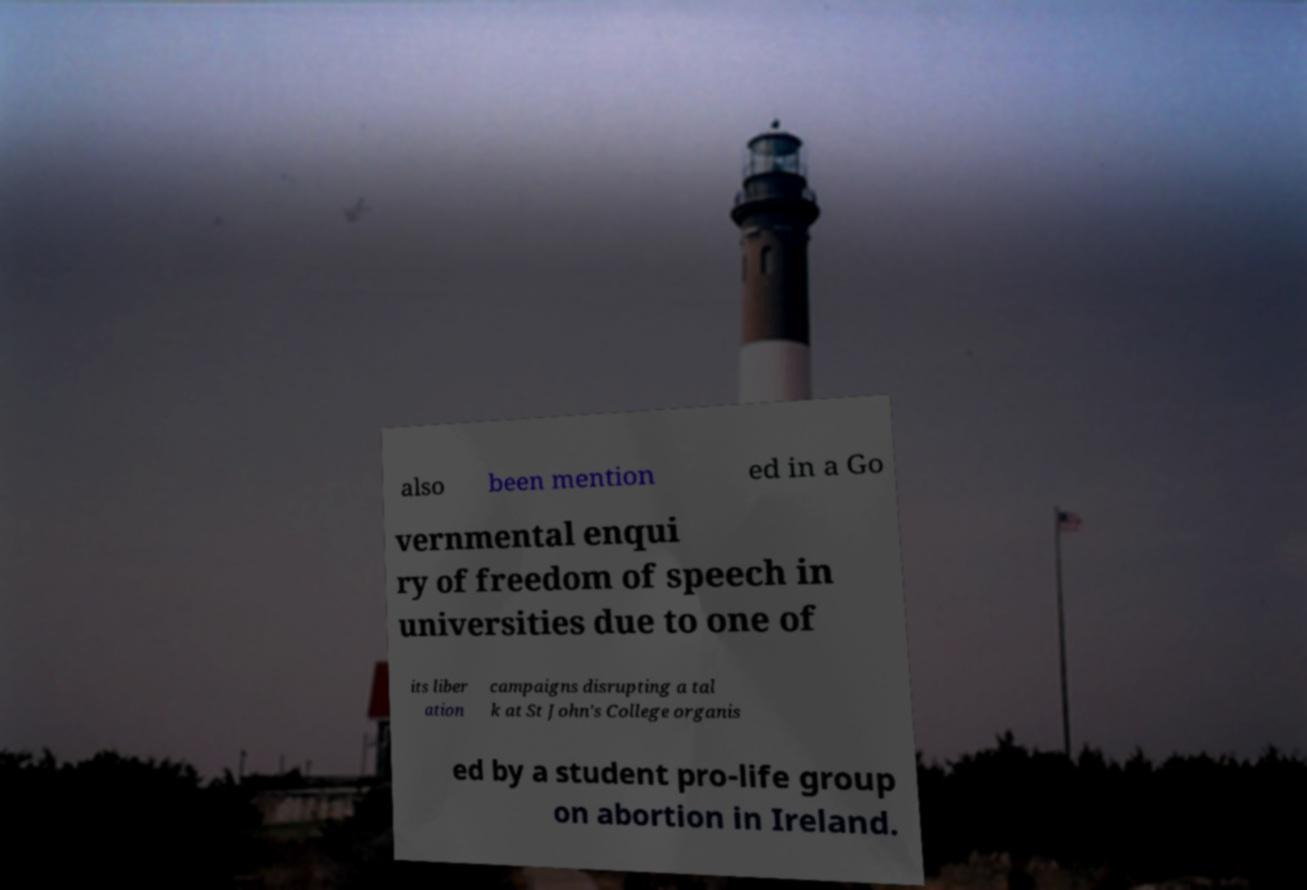Could you assist in decoding the text presented in this image and type it out clearly? also been mention ed in a Go vernmental enqui ry of freedom of speech in universities due to one of its liber ation campaigns disrupting a tal k at St John's College organis ed by a student pro-life group on abortion in Ireland. 